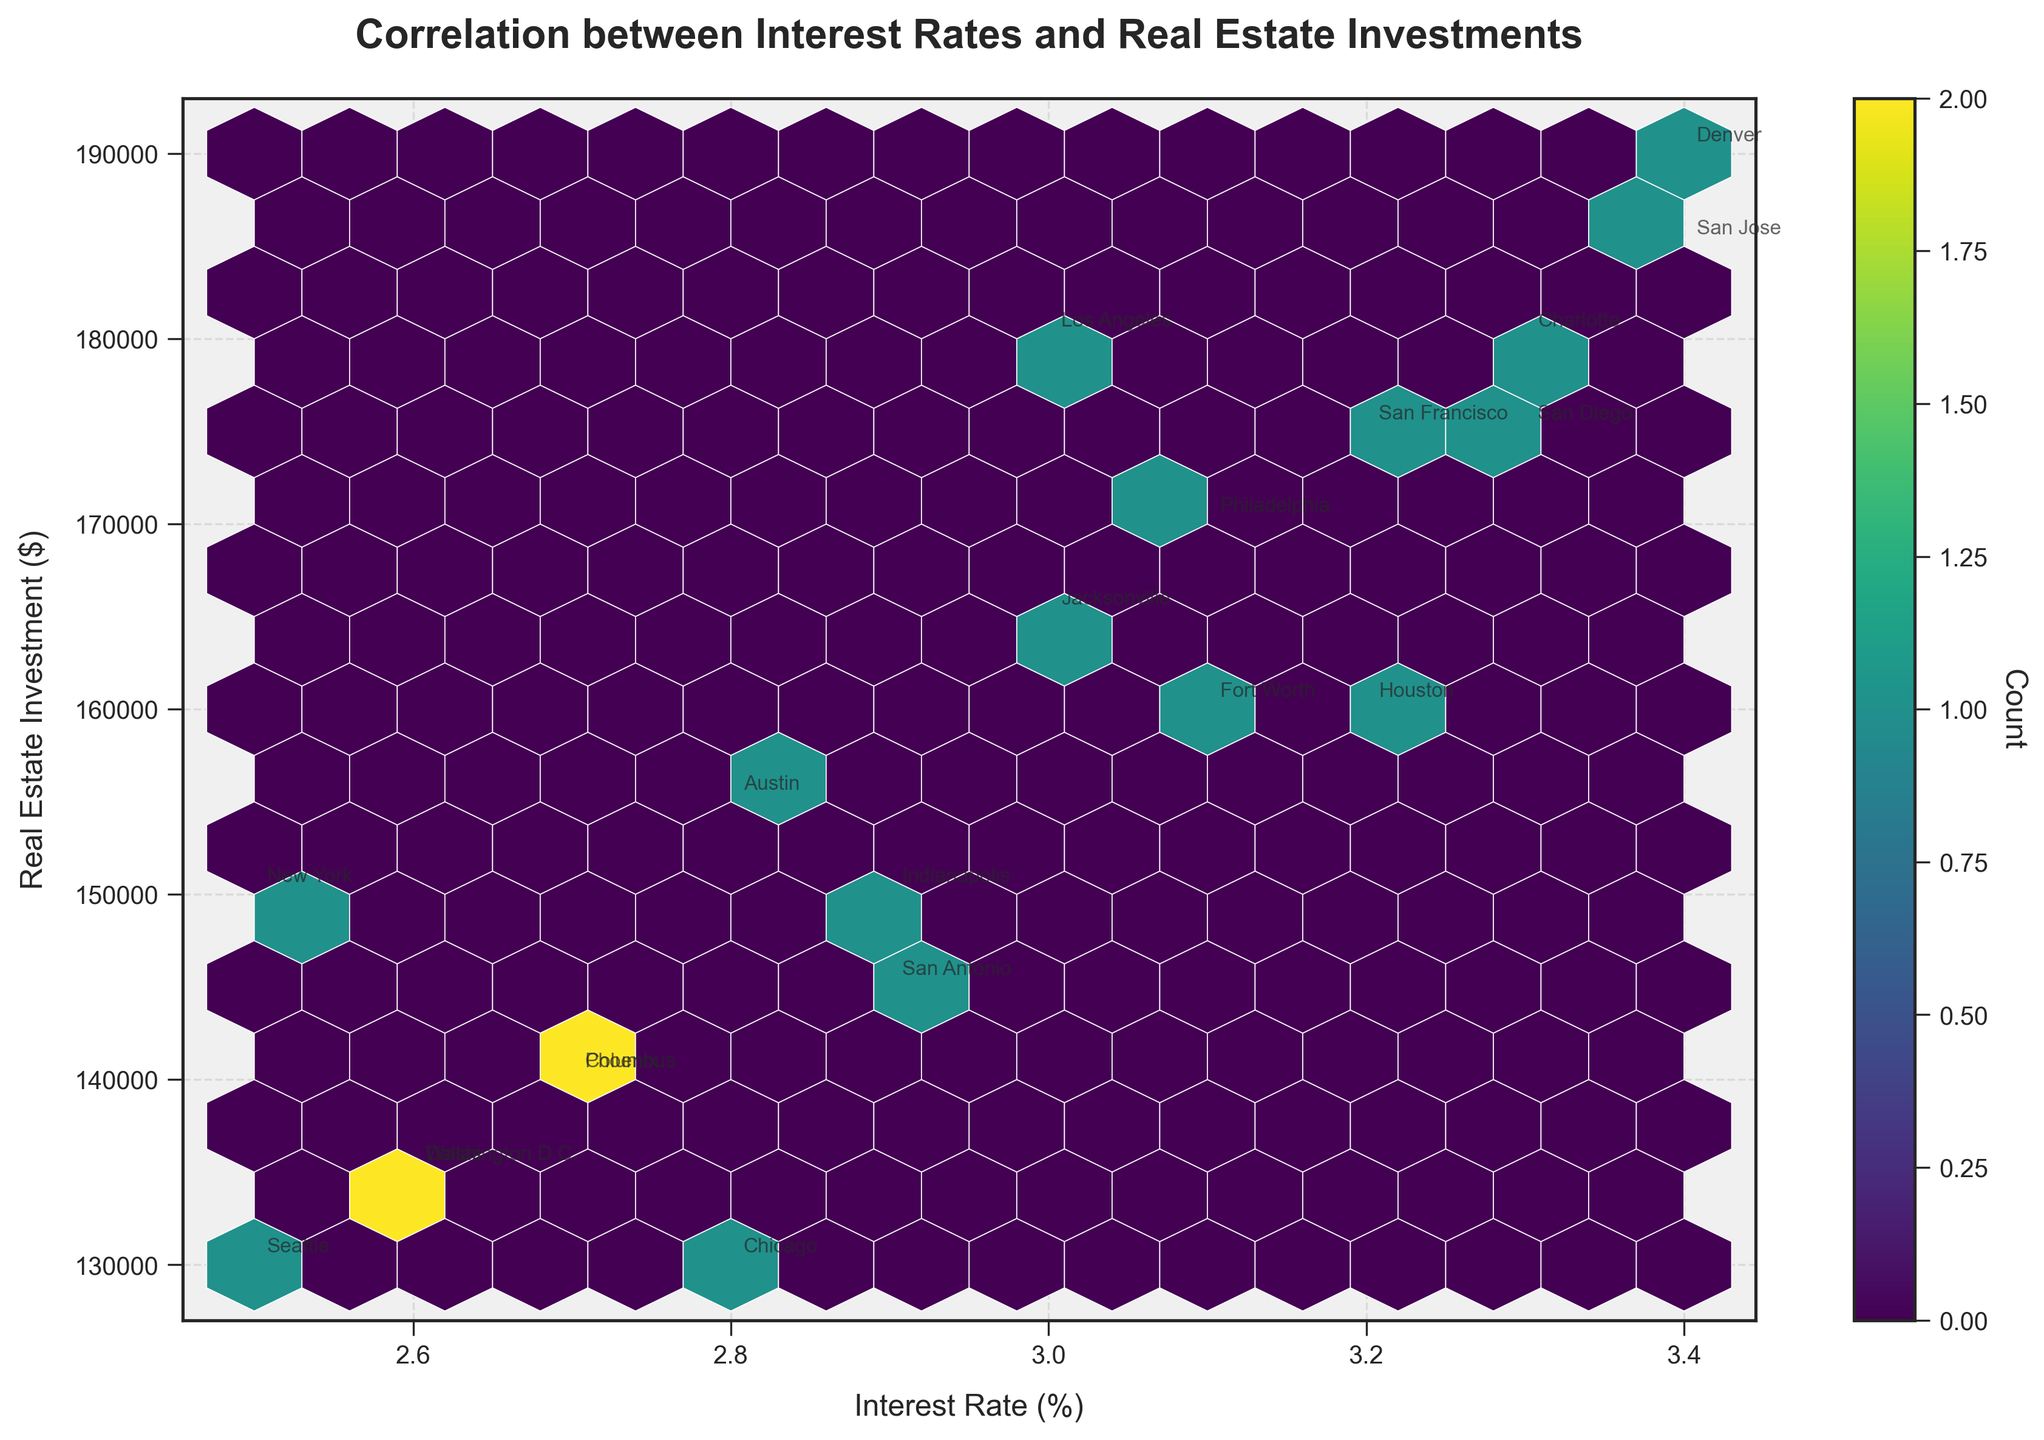What is the title of the plot? The title of a plot is usually found at the top of the figure. In this hexbin plot, the title is displayed at the top center. It reads "Correlation between Interest Rates and Real Estate Investments".
Answer: Correlation between Interest Rates and Real Estate Investments What are the labels on the x and y axes? The labels on the x and y axes describe what each axis represents in the plot. The x-axis is labeled "Interest Rate (%)" and the y-axis is labeled "Real Estate Investment ($)".
Answer: Interest Rate (%); Real Estate Investment ($) What color scale is used in the plot? The color scale in the plot is used to denote the density of data points in each hexagonal bin. In this case, the color scale ranges through shades of 'viridis'. This information can be inferred from the color of the hexagons.
Answer: viridis Which city has the highest real estate investment? To identify the city with the highest real estate investment, we need to look for the highest point on the y-axis and refer to the annotated city. The point with the highest y-value corresponds to San Jose with $185,000.
Answer: San Jose How many data bins are represented in the color bar? The color bar represents the count of data points in each bin. You can count the number of distinct shades displayed on the color bar to find the number of bins. In this case, there are multiple shades, indicating several bins, but an exact count may be tough to discern without exact band numbers.
Answer: Multiple Which cities have an interest rate of 2.5%? By checking the x-axis at the position corresponding to 2.5% and looking for annotated city names, we find that New York and Seattle have an interest rate of 2.5%.
Answer: New York, Seattle What is the correlation trend between interest rates and real estate investments? The correlation trend can be observed by noting the overall direction the hexagon bins are aligned. If bins generally slope upwards as we move right, there's a positive correlation, and if downwards, a negative correlation. Here, there's a slight positive trend, as higher interest rates are associated with higher real estate investments.
Answer: Slight positive Compare the real estate investment amounts in Los Angeles and Chicago. Los Angeles has real estate investment values at $180,000, while Chicago has values at $130,000. Comparing these two values shows that Los Angeles has a higher real estate investment than Chicago.
Answer: Los Angeles > Chicago Which city has the lowest real estate investment at a given interest rate? Identify the lowest point on the y-axis and find the corresponding city from the annotations. Seattle shows a real estate investment of $130,000 at 2.5% interest rate, which is the lowest investment value in the data set.
Answer: Seattle 